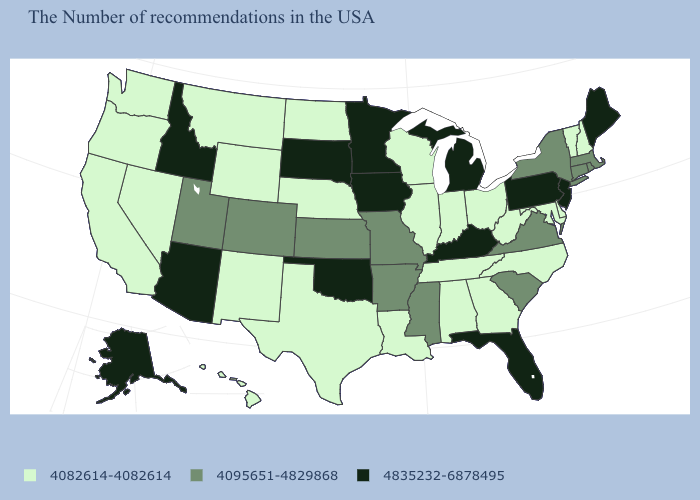What is the value of North Carolina?
Write a very short answer. 4082614-4082614. Name the states that have a value in the range 4082614-4082614?
Concise answer only. New Hampshire, Vermont, Delaware, Maryland, North Carolina, West Virginia, Ohio, Georgia, Indiana, Alabama, Tennessee, Wisconsin, Illinois, Louisiana, Nebraska, Texas, North Dakota, Wyoming, New Mexico, Montana, Nevada, California, Washington, Oregon, Hawaii. What is the value of Vermont?
Quick response, please. 4082614-4082614. What is the value of Iowa?
Short answer required. 4835232-6878495. What is the value of Oklahoma?
Answer briefly. 4835232-6878495. Which states have the lowest value in the Northeast?
Concise answer only. New Hampshire, Vermont. What is the value of South Dakota?
Short answer required. 4835232-6878495. Name the states that have a value in the range 4835232-6878495?
Quick response, please. Maine, New Jersey, Pennsylvania, Florida, Michigan, Kentucky, Minnesota, Iowa, Oklahoma, South Dakota, Arizona, Idaho, Alaska. Name the states that have a value in the range 4835232-6878495?
Answer briefly. Maine, New Jersey, Pennsylvania, Florida, Michigan, Kentucky, Minnesota, Iowa, Oklahoma, South Dakota, Arizona, Idaho, Alaska. Does the first symbol in the legend represent the smallest category?
Concise answer only. Yes. What is the highest value in states that border Kentucky?
Answer briefly. 4095651-4829868. What is the value of Georgia?
Be succinct. 4082614-4082614. What is the value of North Dakota?
Keep it brief. 4082614-4082614. Among the states that border Kentucky , does Ohio have the lowest value?
Write a very short answer. Yes. 